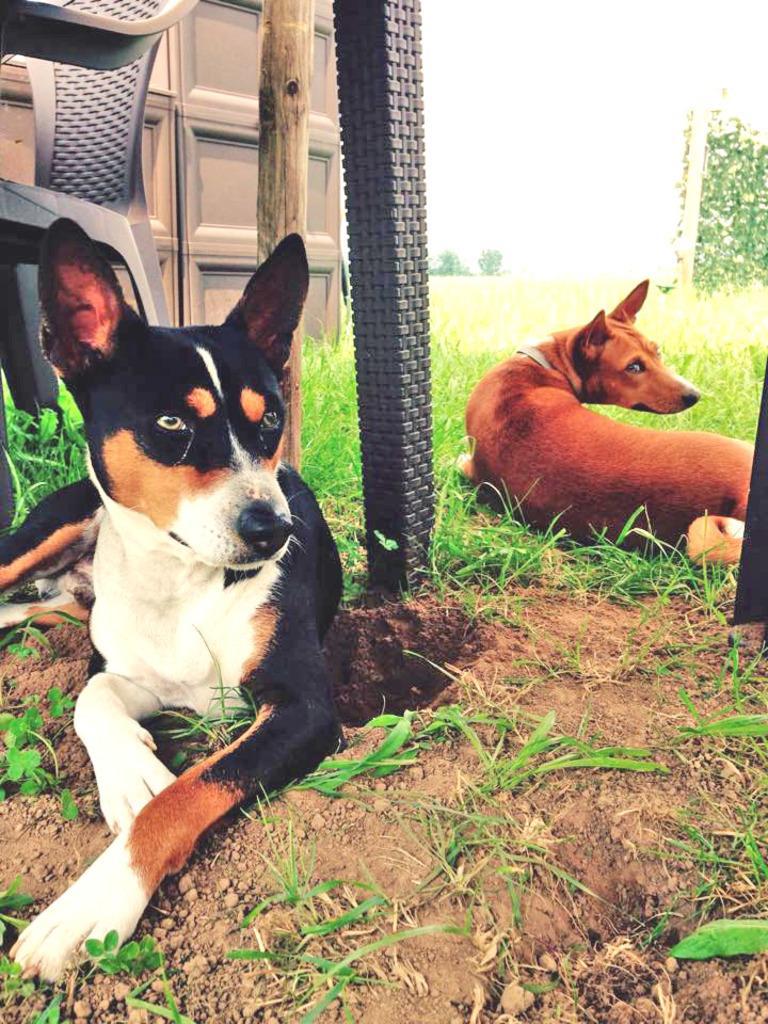In one or two sentences, can you explain what this image depicts? In this image we can see two dogs are sitting on the ground and in the background, we can see the chair, wooden stick, some vehicle, grass and the sky. 